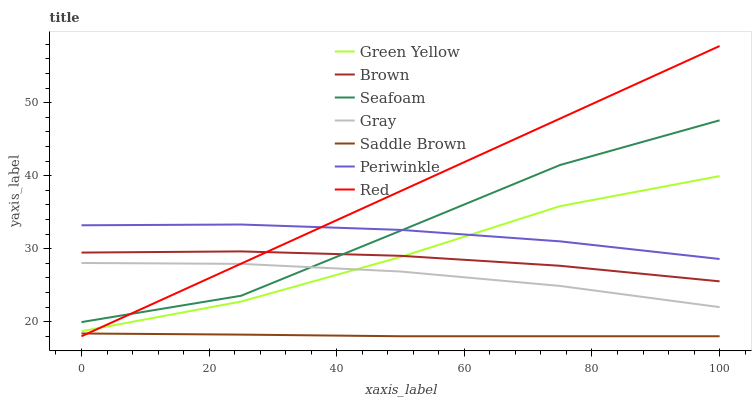Does Saddle Brown have the minimum area under the curve?
Answer yes or no. Yes. Does Red have the maximum area under the curve?
Answer yes or no. Yes. Does Gray have the minimum area under the curve?
Answer yes or no. No. Does Gray have the maximum area under the curve?
Answer yes or no. No. Is Red the smoothest?
Answer yes or no. Yes. Is Seafoam the roughest?
Answer yes or no. Yes. Is Gray the smoothest?
Answer yes or no. No. Is Gray the roughest?
Answer yes or no. No. Does Saddle Brown have the lowest value?
Answer yes or no. Yes. Does Gray have the lowest value?
Answer yes or no. No. Does Red have the highest value?
Answer yes or no. Yes. Does Gray have the highest value?
Answer yes or no. No. Is Green Yellow less than Seafoam?
Answer yes or no. Yes. Is Gray greater than Saddle Brown?
Answer yes or no. Yes. Does Red intersect Saddle Brown?
Answer yes or no. Yes. Is Red less than Saddle Brown?
Answer yes or no. No. Is Red greater than Saddle Brown?
Answer yes or no. No. Does Green Yellow intersect Seafoam?
Answer yes or no. No. 